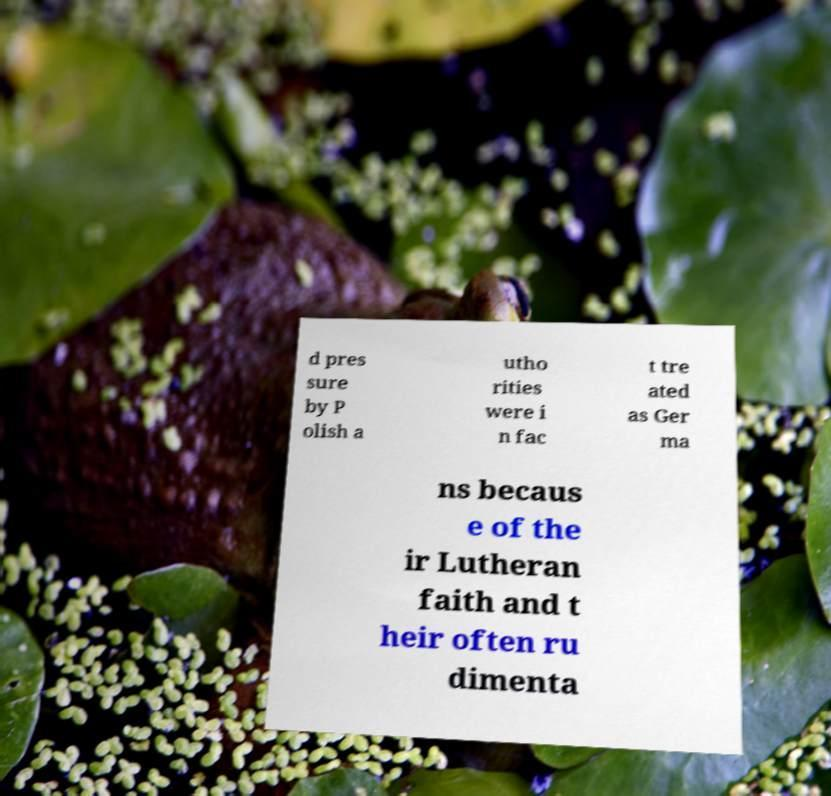Please read and relay the text visible in this image. What does it say? d pres sure by P olish a utho rities were i n fac t tre ated as Ger ma ns becaus e of the ir Lutheran faith and t heir often ru dimenta 